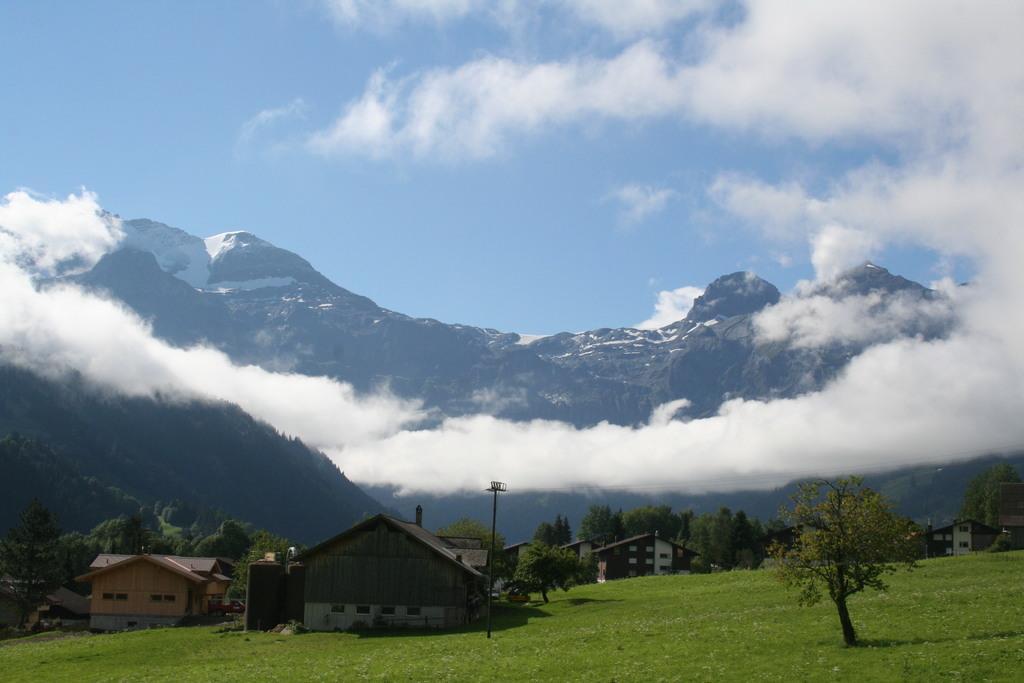How would you summarize this image in a sentence or two? In this picture we can see a beautiful view of the shed houses on the grass ground. Behind there are some trees. In the background there are some mountains with snow. On the top we can see sky and clouds. 